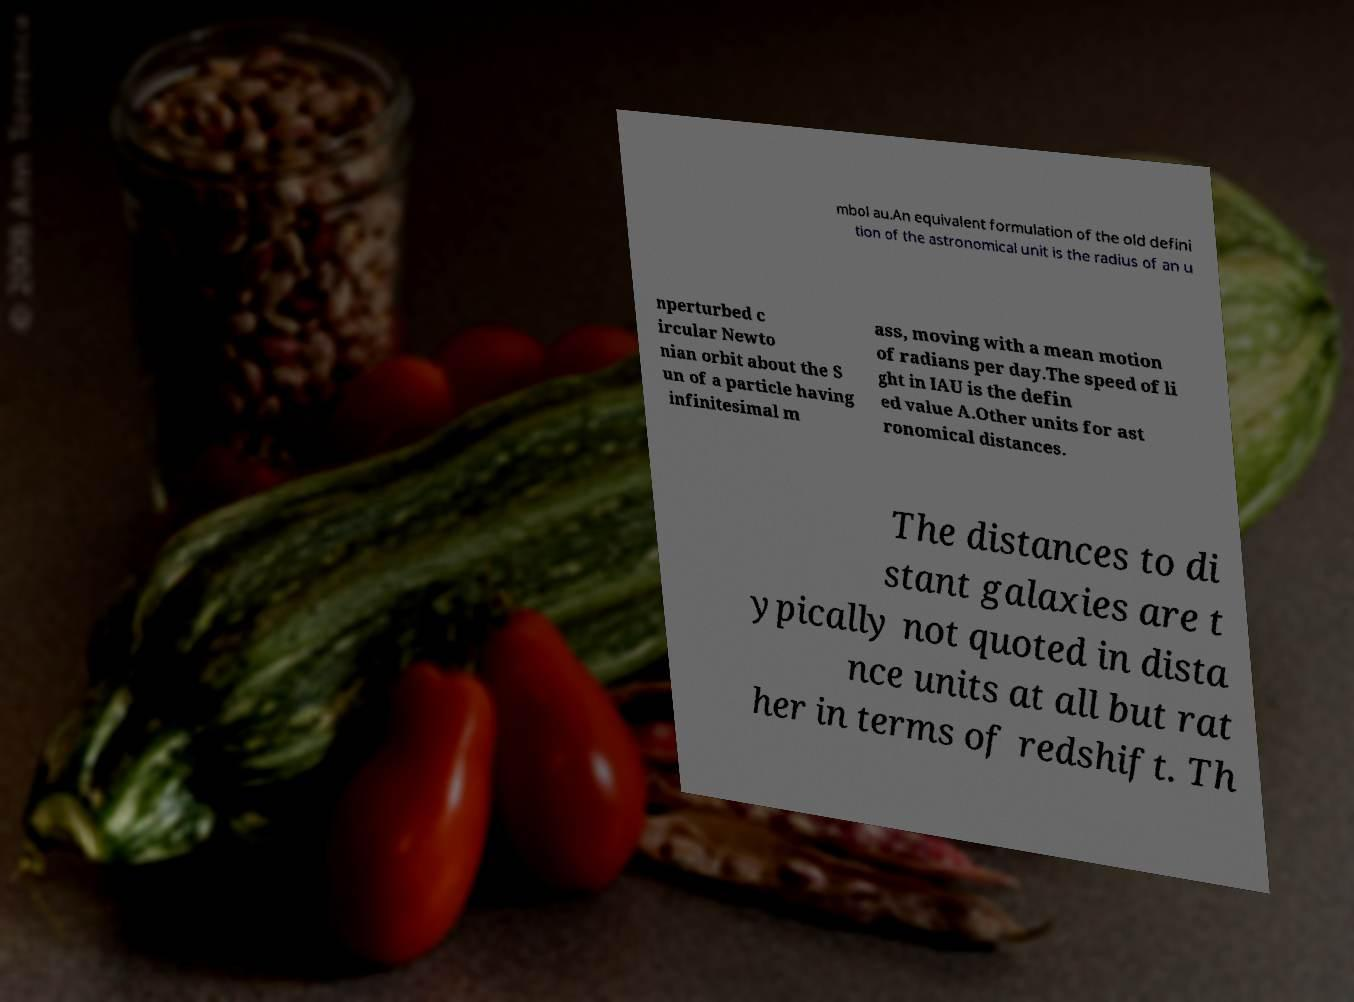There's text embedded in this image that I need extracted. Can you transcribe it verbatim? mbol au.An equivalent formulation of the old defini tion of the astronomical unit is the radius of an u nperturbed c ircular Newto nian orbit about the S un of a particle having infinitesimal m ass, moving with a mean motion of radians per day.The speed of li ght in IAU is the defin ed value A.Other units for ast ronomical distances. The distances to di stant galaxies are t ypically not quoted in dista nce units at all but rat her in terms of redshift. Th 